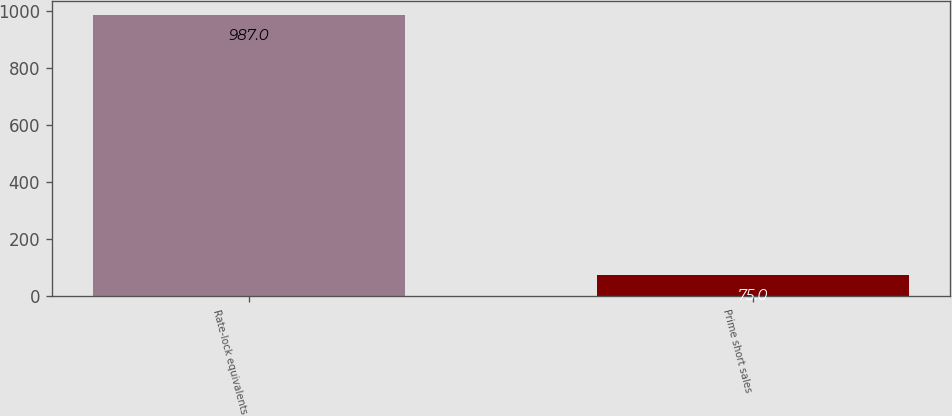Convert chart to OTSL. <chart><loc_0><loc_0><loc_500><loc_500><bar_chart><fcel>Rate-lock equivalents<fcel>Prime short sales<nl><fcel>987<fcel>75<nl></chart> 